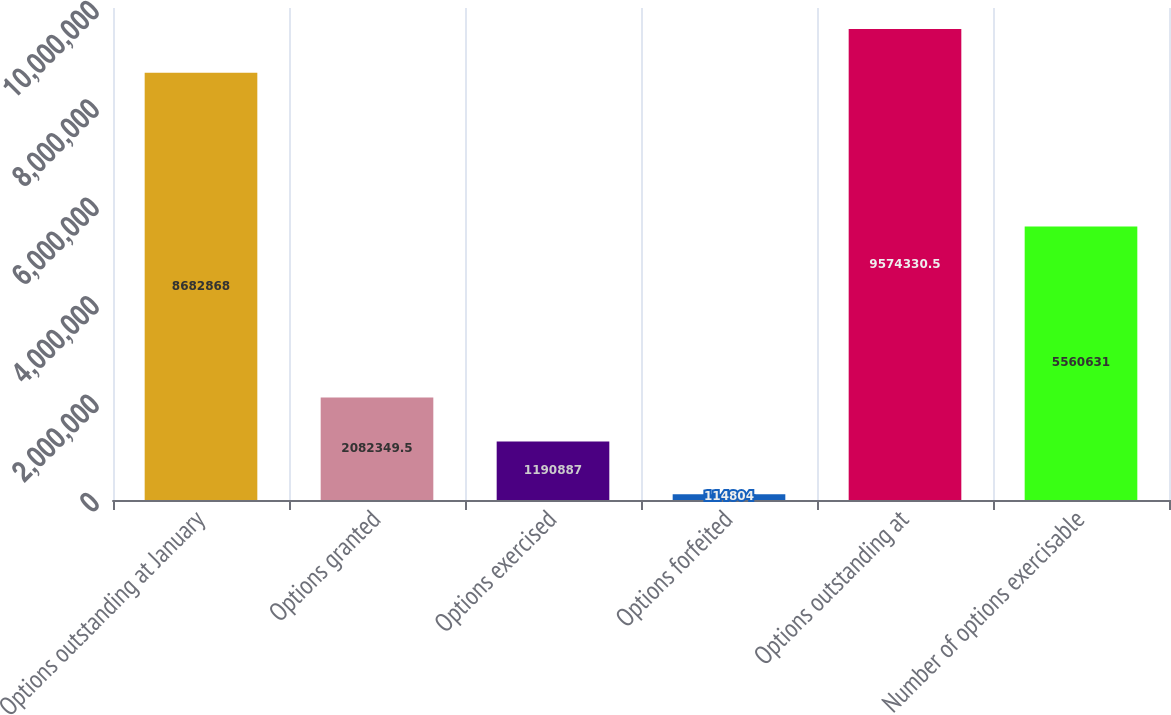Convert chart. <chart><loc_0><loc_0><loc_500><loc_500><bar_chart><fcel>Options outstanding at January<fcel>Options granted<fcel>Options exercised<fcel>Options forfeited<fcel>Options outstanding at<fcel>Number of options exercisable<nl><fcel>8.68287e+06<fcel>2.08235e+06<fcel>1.19089e+06<fcel>114804<fcel>9.57433e+06<fcel>5.56063e+06<nl></chart> 